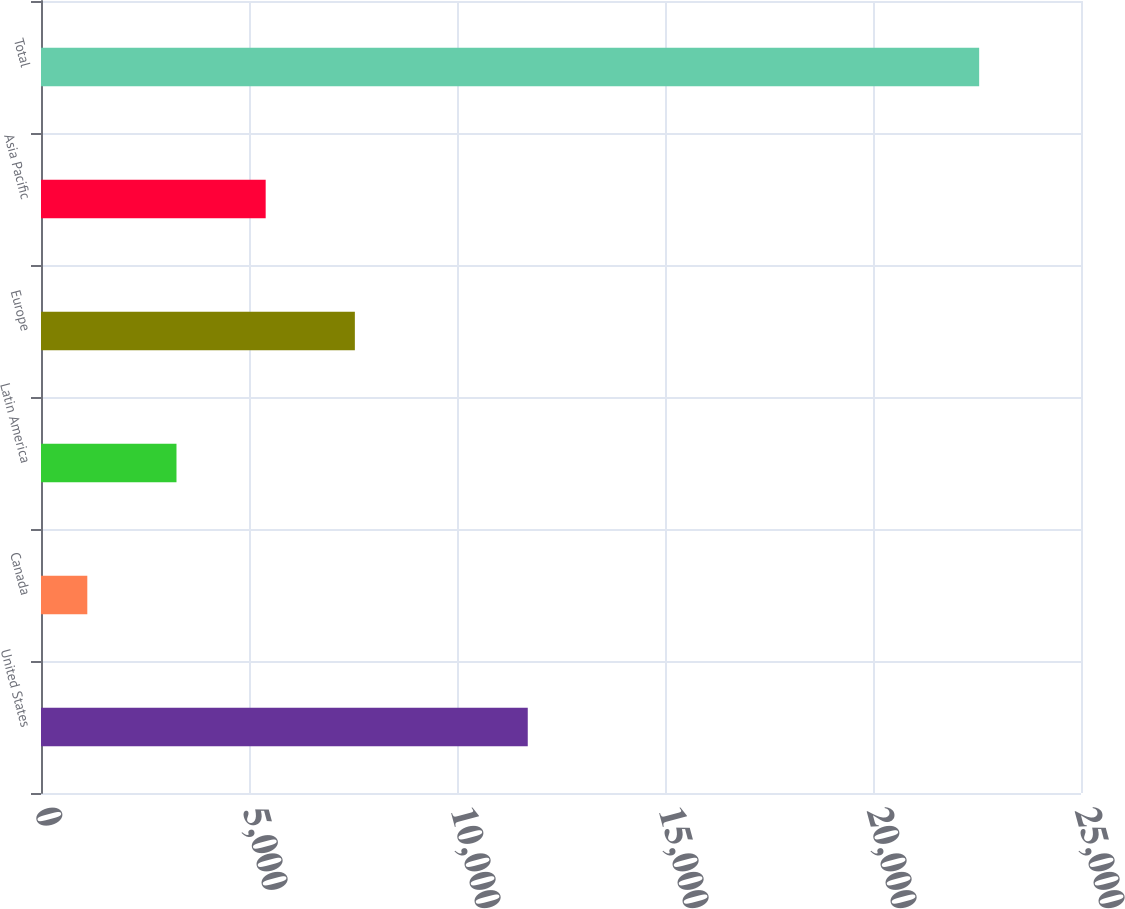Convert chart. <chart><loc_0><loc_0><loc_500><loc_500><bar_chart><fcel>United States<fcel>Canada<fcel>Latin America<fcel>Europe<fcel>Asia Pacific<fcel>Total<nl><fcel>11701<fcel>1113<fcel>3256.9<fcel>7544.7<fcel>5400.8<fcel>22552<nl></chart> 